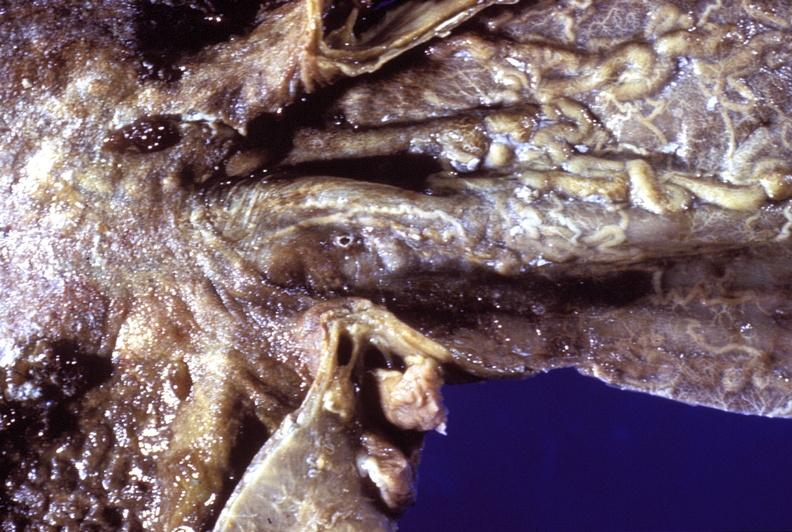s newborn cord around neck present?
Answer the question using a single word or phrase. No 